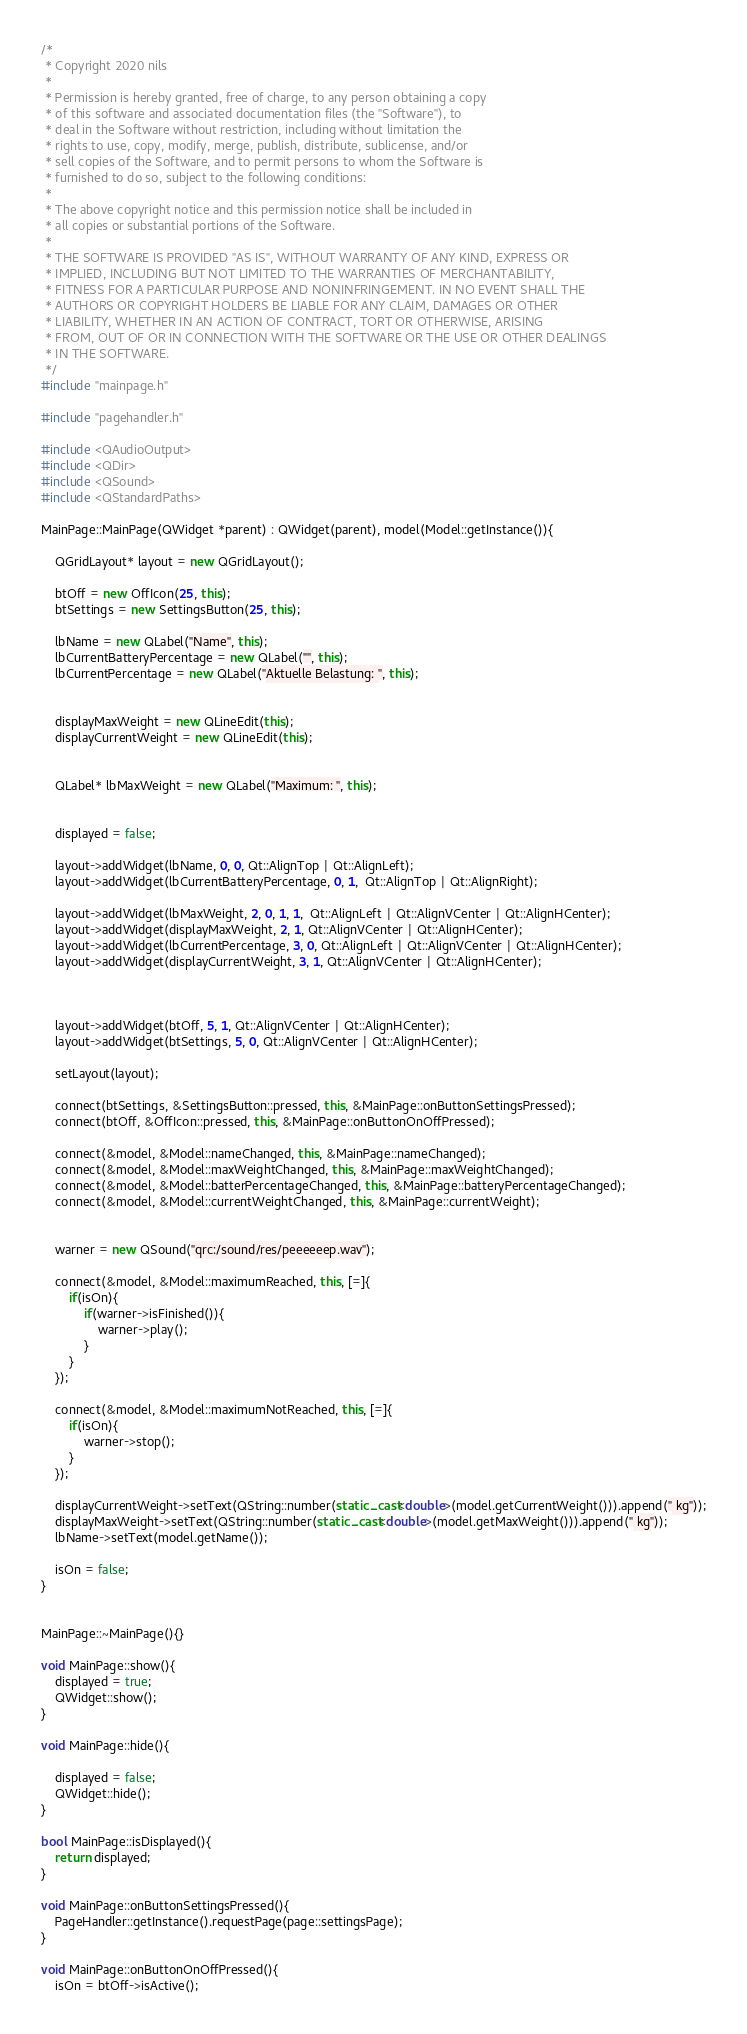<code> <loc_0><loc_0><loc_500><loc_500><_C++_>/*
 * Copyright 2020 nils
 *
 * Permission is hereby granted, free of charge, to any person obtaining a copy
 * of this software and associated documentation files (the "Software"), to
 * deal in the Software without restriction, including without limitation the
 * rights to use, copy, modify, merge, publish, distribute, sublicense, and/or
 * sell copies of the Software, and to permit persons to whom the Software is
 * furnished to do so, subject to the following conditions:
 *
 * The above copyright notice and this permission notice shall be included in
 * all copies or substantial portions of the Software.
 *
 * THE SOFTWARE IS PROVIDED "AS IS", WITHOUT WARRANTY OF ANY KIND, EXPRESS OR
 * IMPLIED, INCLUDING BUT NOT LIMITED TO THE WARRANTIES OF MERCHANTABILITY,
 * FITNESS FOR A PARTICULAR PURPOSE AND NONINFRINGEMENT. IN NO EVENT SHALL THE
 * AUTHORS OR COPYRIGHT HOLDERS BE LIABLE FOR ANY CLAIM, DAMAGES OR OTHER
 * LIABILITY, WHETHER IN AN ACTION OF CONTRACT, TORT OR OTHERWISE, ARISING
 * FROM, OUT OF OR IN CONNECTION WITH THE SOFTWARE OR THE USE OR OTHER DEALINGS
 * IN THE SOFTWARE.
 */
#include "mainpage.h"

#include "pagehandler.h"

#include <QAudioOutput>
#include <QDir>
#include <QSound>
#include <QStandardPaths>

MainPage::MainPage(QWidget *parent) : QWidget(parent), model(Model::getInstance()){

    QGridLayout* layout = new QGridLayout();

    btOff = new OffIcon(25, this);
    btSettings = new SettingsButton(25, this);

    lbName = new QLabel("Name", this);
    lbCurrentBatteryPercentage = new QLabel("", this);
    lbCurrentPercentage = new QLabel("Aktuelle Belastung: ", this);


    displayMaxWeight = new QLineEdit(this);
    displayCurrentWeight = new QLineEdit(this);


    QLabel* lbMaxWeight = new QLabel("Maximum: ", this);


    displayed = false;

    layout->addWidget(lbName, 0, 0, Qt::AlignTop | Qt::AlignLeft);
    layout->addWidget(lbCurrentBatteryPercentage, 0, 1,  Qt::AlignTop | Qt::AlignRight);

    layout->addWidget(lbMaxWeight, 2, 0, 1, 1,  Qt::AlignLeft | Qt::AlignVCenter | Qt::AlignHCenter);
    layout->addWidget(displayMaxWeight, 2, 1, Qt::AlignVCenter | Qt::AlignHCenter);
    layout->addWidget(lbCurrentPercentage, 3, 0, Qt::AlignLeft | Qt::AlignVCenter | Qt::AlignHCenter);
    layout->addWidget(displayCurrentWeight, 3, 1, Qt::AlignVCenter | Qt::AlignHCenter);



    layout->addWidget(btOff, 5, 1, Qt::AlignVCenter | Qt::AlignHCenter);
    layout->addWidget(btSettings, 5, 0, Qt::AlignVCenter | Qt::AlignHCenter);

    setLayout(layout);

    connect(btSettings, &SettingsButton::pressed, this, &MainPage::onButtonSettingsPressed);
    connect(btOff, &OffIcon::pressed, this, &MainPage::onButtonOnOffPressed);

    connect(&model, &Model::nameChanged, this, &MainPage::nameChanged);
    connect(&model, &Model::maxWeightChanged, this, &MainPage::maxWeightChanged);
    connect(&model, &Model::batterPercentageChanged, this, &MainPage::batteryPercentageChanged);
    connect(&model, &Model::currentWeightChanged, this, &MainPage::currentWeight);


    warner = new QSound("qrc:/sound/res/peeeeeep.wav");

    connect(&model, &Model::maximumReached, this, [=]{
        if(isOn){
            if(warner->isFinished()){
                warner->play();
            }
        }
    });

    connect(&model, &Model::maximumNotReached, this, [=]{
        if(isOn){
            warner->stop();
        }
    });

    displayCurrentWeight->setText(QString::number(static_cast<double>(model.getCurrentWeight())).append(" kg"));
    displayMaxWeight->setText(QString::number(static_cast<double>(model.getMaxWeight())).append(" kg"));
    lbName->setText(model.getName());

    isOn = false;
}


MainPage::~MainPage(){}

void MainPage::show(){
    displayed = true;
    QWidget::show();
}

void MainPage::hide(){

    displayed = false;
    QWidget::hide();
}

bool MainPage::isDisplayed(){
    return displayed;
}

void MainPage::onButtonSettingsPressed(){
    PageHandler::getInstance().requestPage(page::settingsPage);
}

void MainPage::onButtonOnOffPressed(){
    isOn = btOff->isActive();</code> 